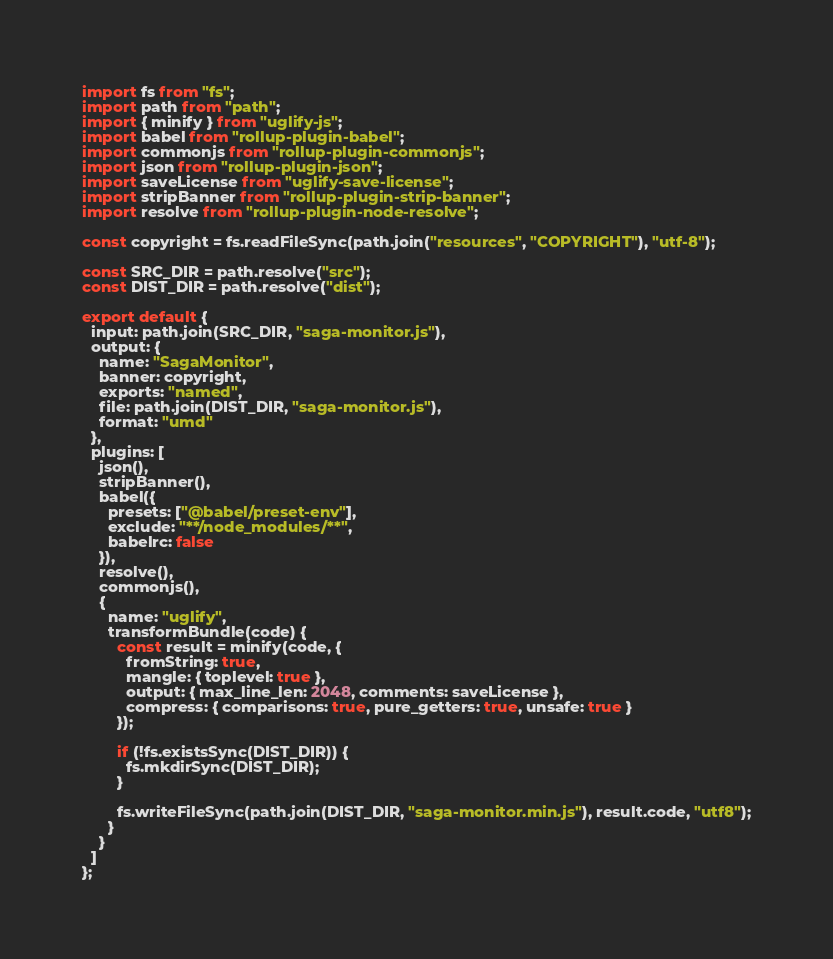Convert code to text. <code><loc_0><loc_0><loc_500><loc_500><_JavaScript_>import fs from "fs";
import path from "path";
import { minify } from "uglify-js";
import babel from "rollup-plugin-babel";
import commonjs from "rollup-plugin-commonjs";
import json from "rollup-plugin-json";
import saveLicense from "uglify-save-license";
import stripBanner from "rollup-plugin-strip-banner";
import resolve from "rollup-plugin-node-resolve";

const copyright = fs.readFileSync(path.join("resources", "COPYRIGHT"), "utf-8");

const SRC_DIR = path.resolve("src");
const DIST_DIR = path.resolve("dist");

export default {
  input: path.join(SRC_DIR, "saga-monitor.js"),
  output: {
    name: "SagaMonitor",
    banner: copyright,
    exports: "named",
    file: path.join(DIST_DIR, "saga-monitor.js"),
    format: "umd"
  },
  plugins: [
    json(),
    stripBanner(),
    babel({
      presets: ["@babel/preset-env"],
      exclude: "**/node_modules/**",
      babelrc: false
    }),
    resolve(),
    commonjs(),
    {
      name: "uglify",
      transformBundle(code) {
        const result = minify(code, {
          fromString: true,
          mangle: { toplevel: true },
          output: { max_line_len: 2048, comments: saveLicense },
          compress: { comparisons: true, pure_getters: true, unsafe: true }
        });

        if (!fs.existsSync(DIST_DIR)) {
          fs.mkdirSync(DIST_DIR);
        }

        fs.writeFileSync(path.join(DIST_DIR, "saga-monitor.min.js"), result.code, "utf8");
      }
    }
  ]
};
</code> 